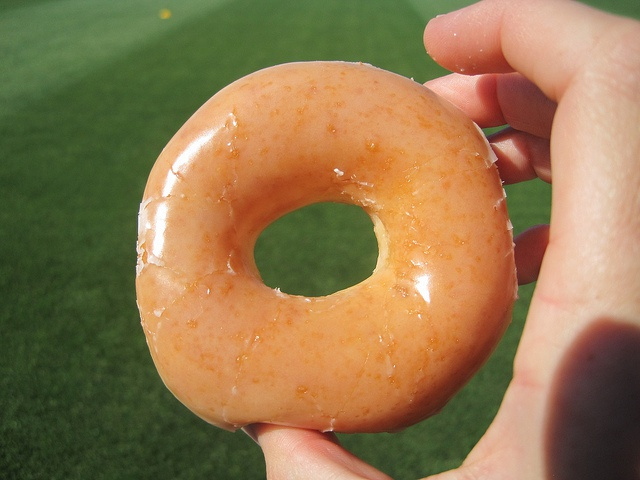Describe the objects in this image and their specific colors. I can see donut in darkgreen, tan, brown, and red tones and people in darkgreen, tan, maroon, and black tones in this image. 